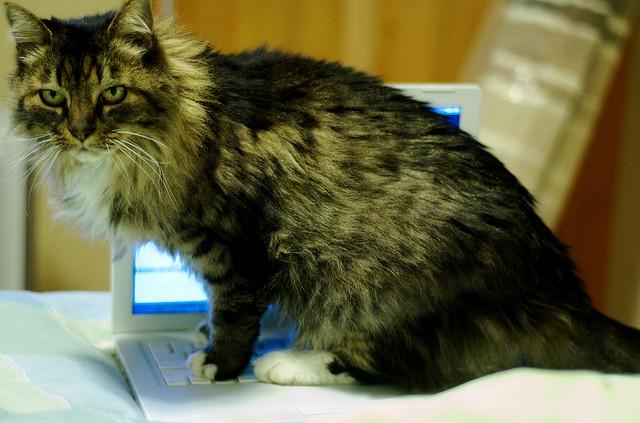What color is the cat's eyes?
Answer briefly. Green. Describe the emotion of the cat?
Concise answer only. Mad. Does this animal look happy?
Keep it brief. No. What kind of animal is this?
Answer briefly. Cat. What breed of cat is this?
Be succinct. Domestic long hair. Will anyone be using the laptop soon?
Keep it brief. No. Is this an adult?
Short answer required. Yes. 